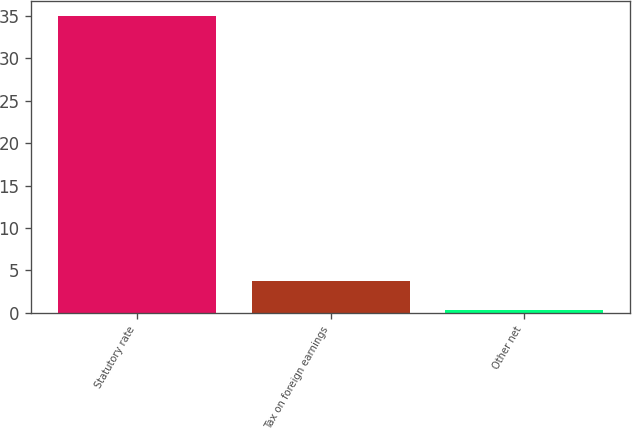Convert chart. <chart><loc_0><loc_0><loc_500><loc_500><bar_chart><fcel>Statutory rate<fcel>Tax on foreign earnings<fcel>Other net<nl><fcel>35<fcel>3.8<fcel>0.3<nl></chart> 